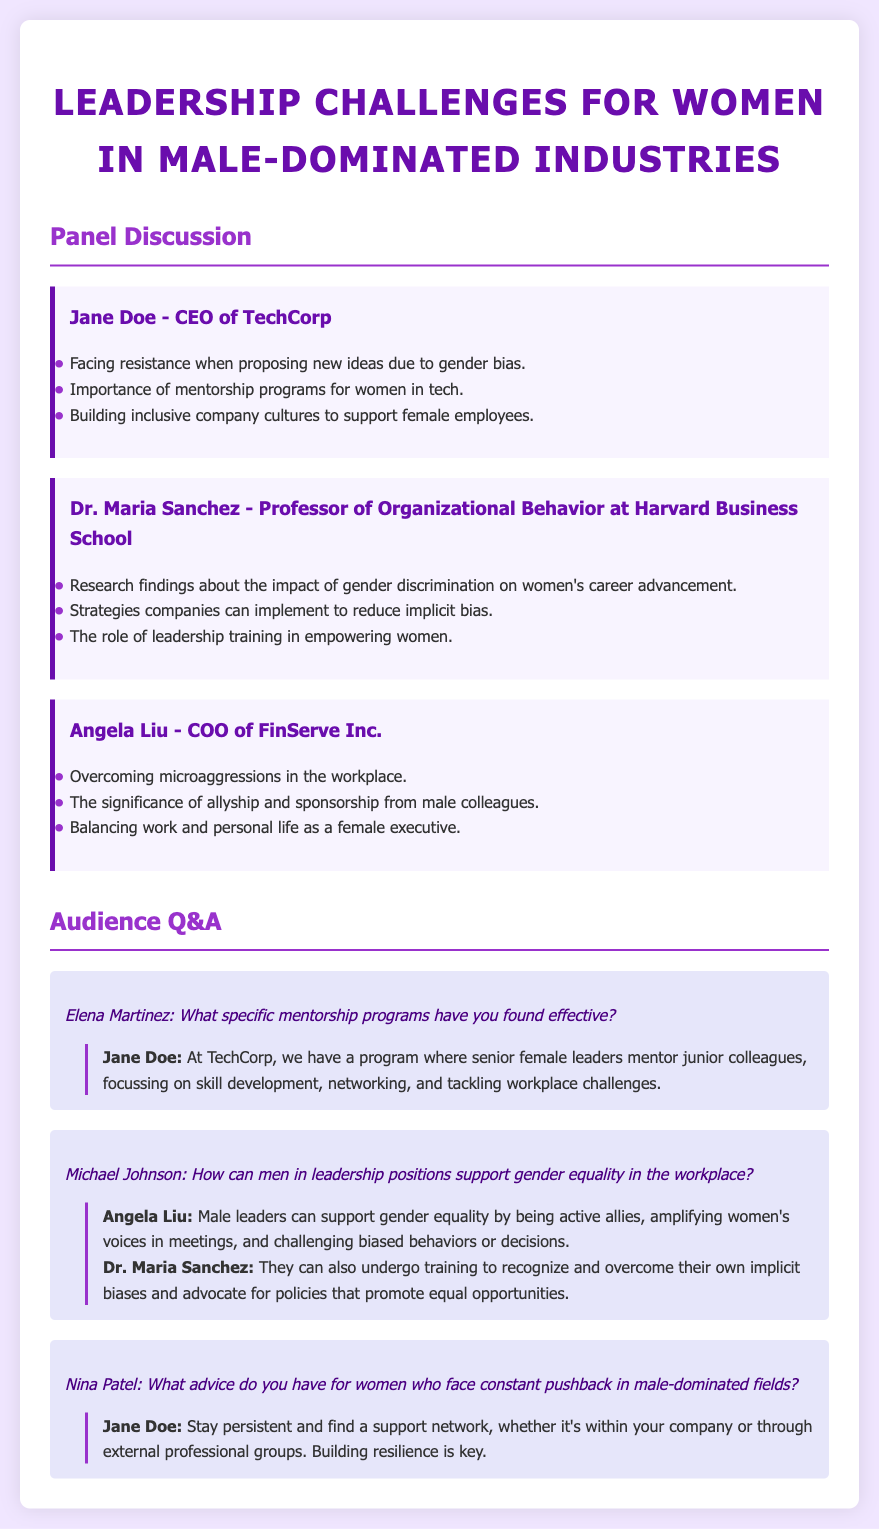What is the title of the conference? The title of the conference is found in the document's header, highlighting the focus on women's leadership in specific industries.
Answer: Leadership Challenges for Women in Male-Dominated Industries Who is the CEO of TechCorp? The document specifies several panelists along with their titles and companies, identifying the CEO of TechCorp.
Answer: Jane Doe What is Dr. Maria Sanchez's profession? The document provides professions for each panelist, indicating that Dr. Maria Sanchez has a specific academic role.
Answer: Professor of Organizational Behavior What does Angela Liu emphasize about male colleagues? The document outlines key points made by each panelist, particularly Angela Liu's insights on the importance of certain relationships in the workplace.
Answer: Allyship and sponsorship What specific program does TechCorp have for mentorship? The audience Q&A section reveals specific details about mentorship programs at TechCorp, as discussed by Jane Doe.
Answer: Senior female leaders mentor junior colleagues How can male leaders support gender equality? Angela Liu and Dr. Maria Sanchez provide insights during the Q&A segment regarding the actions male leaders can take in the context of gender equality.
Answer: Active allies What key issue does Jane Doe mention regarding new ideas? Each panelist addresses challenges they face in their roles, with Jane Doe mentioning an important barrier in her work environment.
Answer: Gender bias What advice does Jane Doe give for facing pushback? In response to audience inquiries, Jane Doe offers specific advice for women dealing with challenges in male-dominated fields.
Answer: Stay persistent and find a support network 